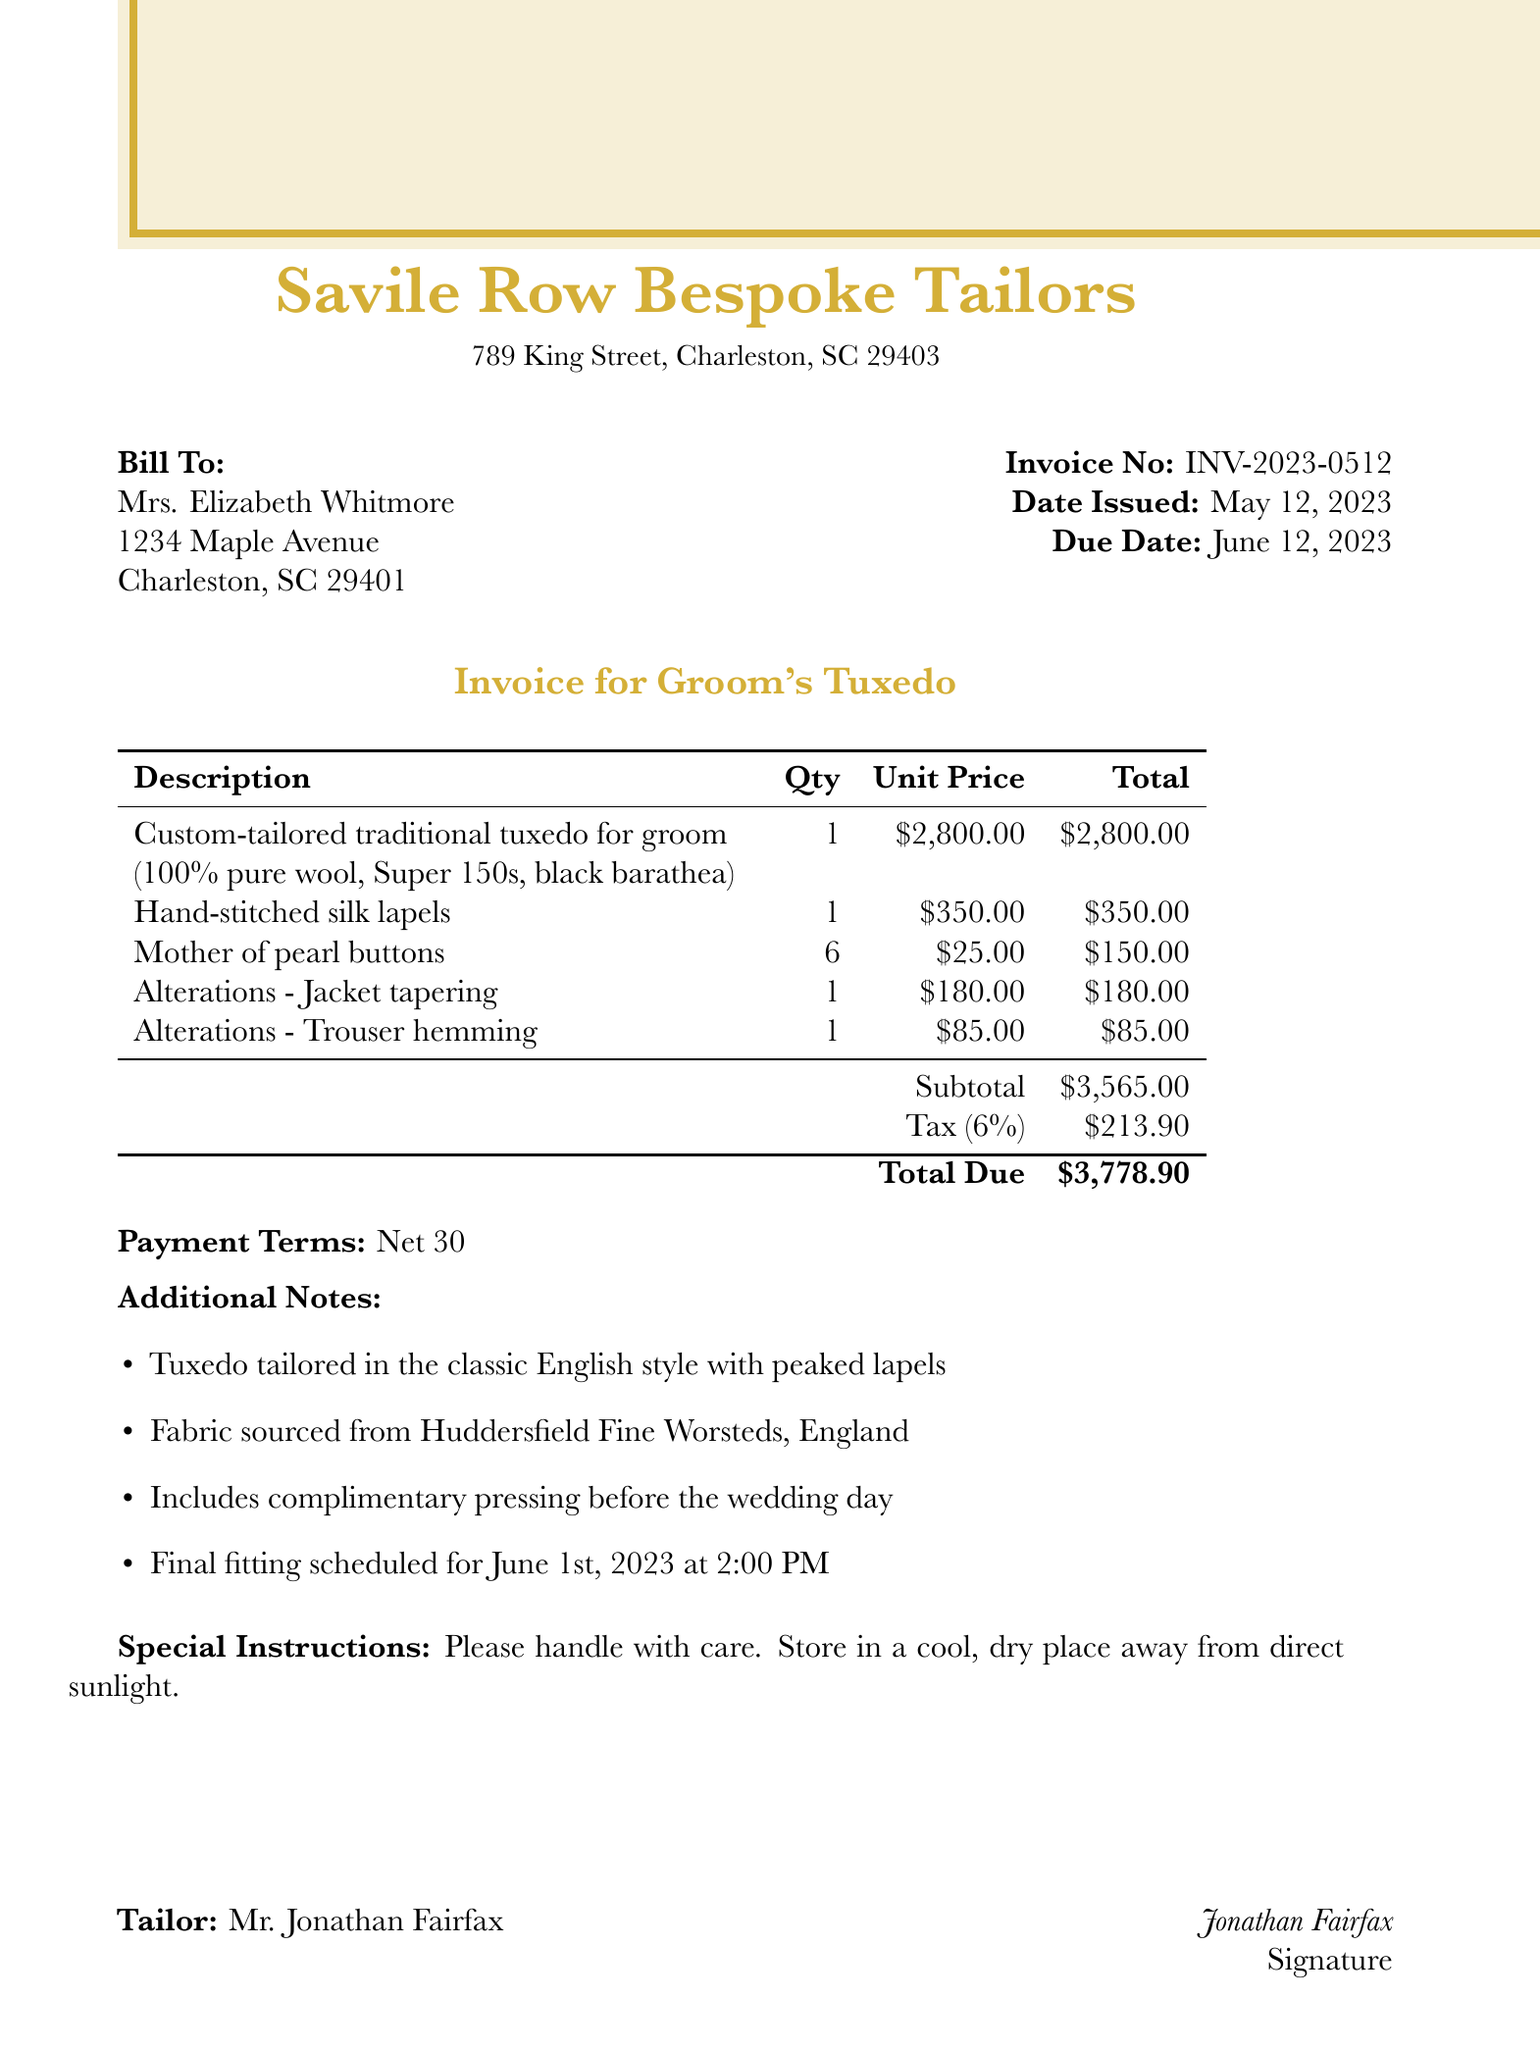What is the invoice number? The invoice number is prominently listed near the top of the document.
Answer: INV-2023-0512 What is the client's name? The client's name is stated clearly in the "Bill To" section.
Answer: Mrs. Elizabeth Whitmore What is the total due amount? The total due is calculated and shown at the bottom of the invoice.
Answer: $3,778.90 What is the unit price for the custom-tailored tuxedo? The unit price for the tuxedo is included in the itemized list.
Answer: $2,800.00 What alteration is mentioned for the trousers? The alterations for the trousers are detailed in the list of services provided.
Answer: Trouser hemming What is the fabric used for the tuxedo? The fabric details are specified in the item description for the tuxedo.
Answer: 100% pure wool, Super 150s, black barathea What is the payment term? The payment terms are stated towards the end of the document.
Answer: Net 30 How many mother of pearl buttons are included? The quantity of mother of pearl buttons is provided in the itemized list.
Answer: 6 When is the final fitting scheduled? The date and time for the final fitting are noted in the additional notes section.
Answer: June 1st, 2023 at 2:00 PM 